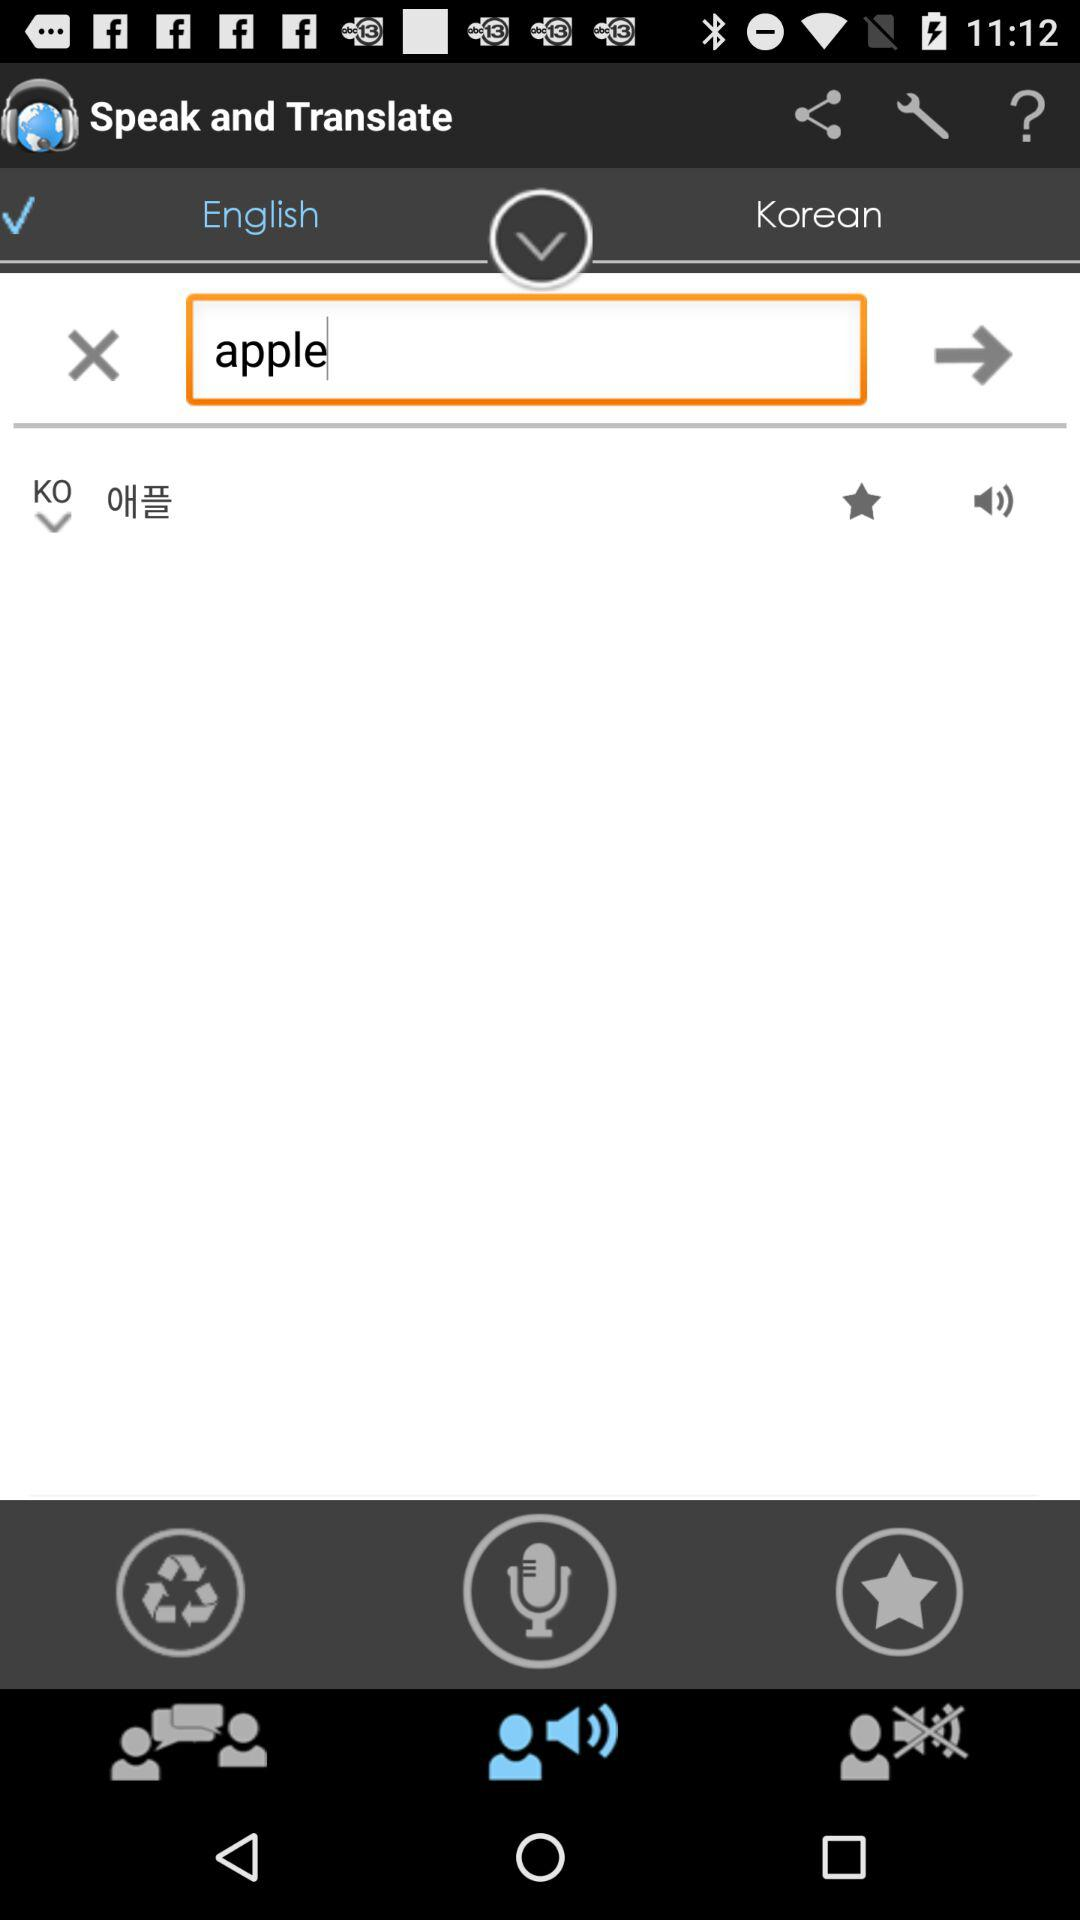How many languages are available for selection?
Answer the question using a single word or phrase. 2 